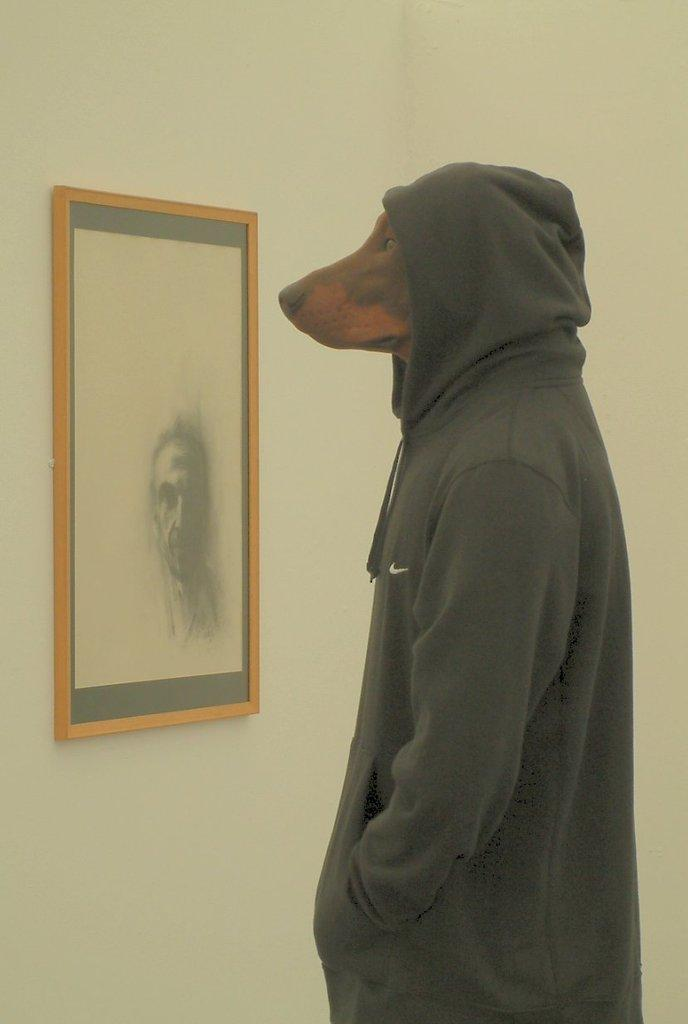What type of animal is wearing a dress in the image? There is a dog with a dress on the right side of the image. What can be seen on the left side of the image? There is a photo frame attached to a pole on the left side of the image. What is the color of the background in the image? The background color is cream. What type of clock is visible in the image? There is no clock present in the image. Is there any dirt visible on the dog's dress in the image? The image does not show any dirt on the dog's dress. 